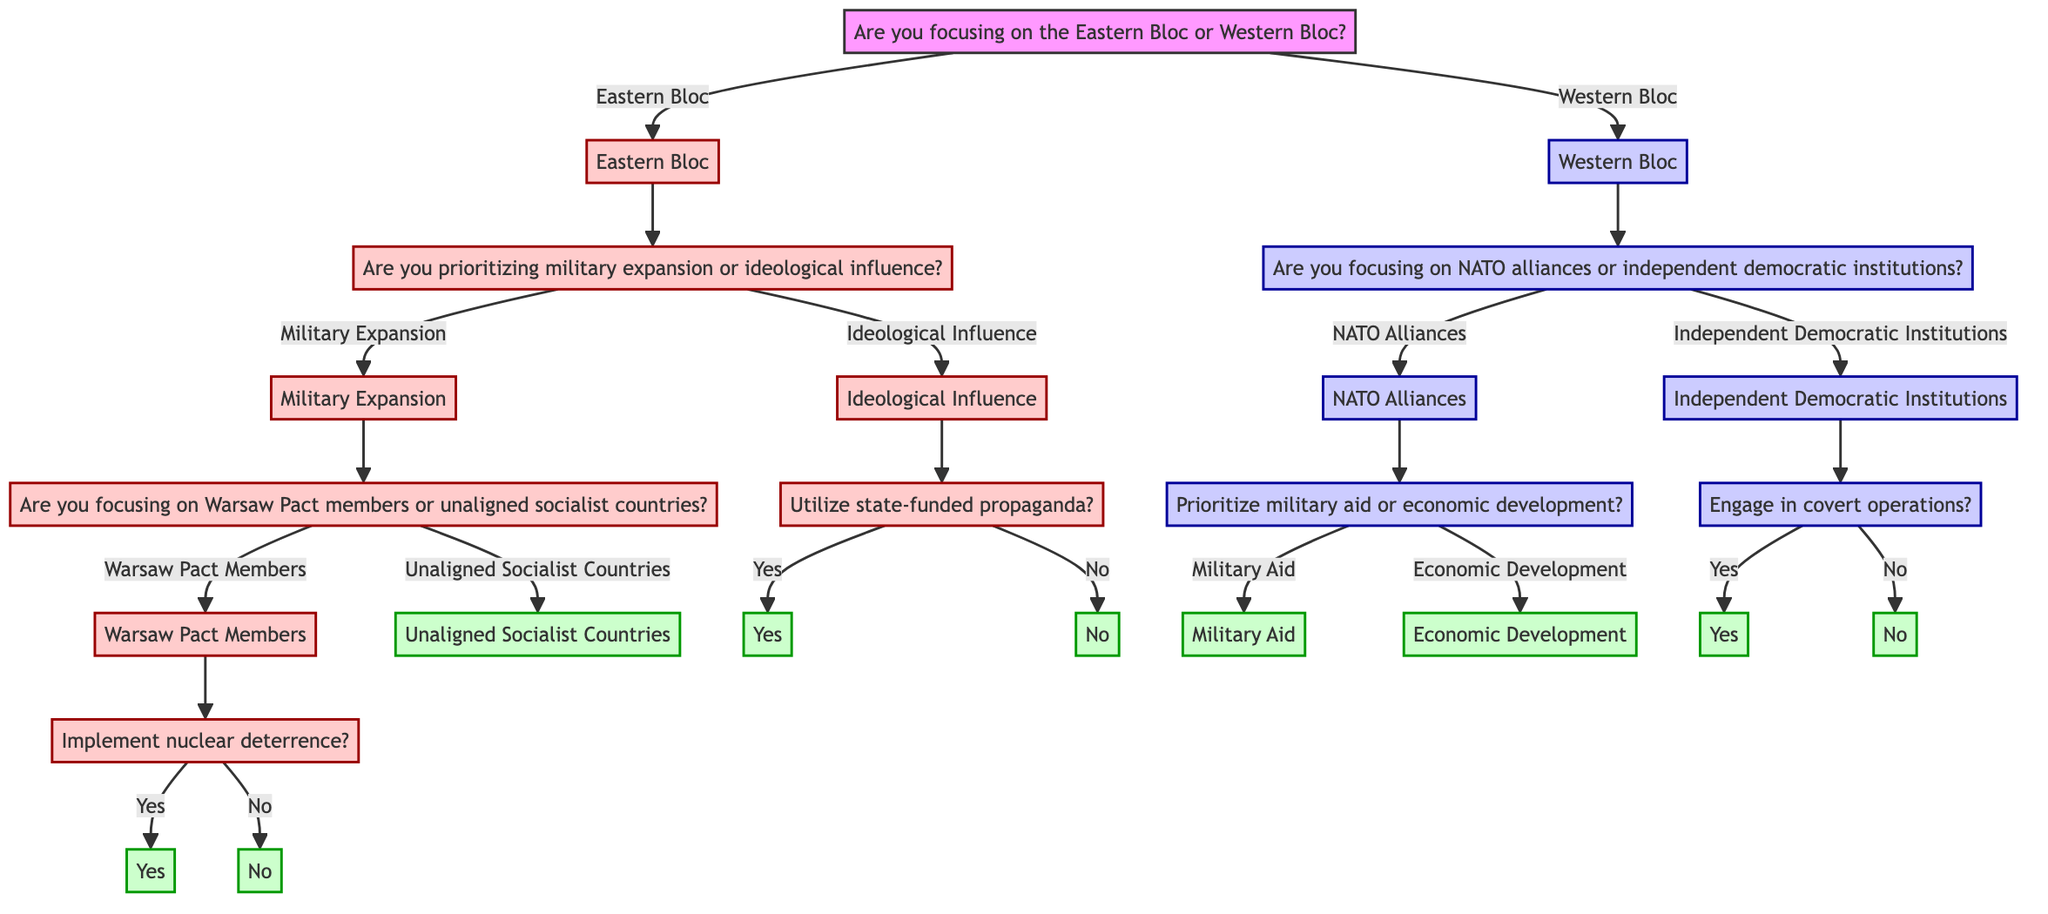What is the first question in the decision tree? The first question, located at the root node, is "Are you focusing on the Eastern Bloc or Western Bloc?" which directs the flow of the decision-making process based on the player's focus.
Answer: Are you focusing on the Eastern Bloc or Western Bloc? How many options are available for the Eastern Bloc strategy? The Eastern Bloc strategy presents two main options: "Military Expansion" and "Ideological Influence." Both options branch out into further questions or results, thus there are two main options to choose from.
Answer: Two Which result comes from prioritizing military expansion and focusing on unaligned socialist countries? Choosing military expansion and focusing on unaligned socialist countries leads to the result: "Offering military aid and economic support to gain influence." This is derived from the flow of choices starting from military expansion down to the specific country focus.
Answer: Offering military aid and economic support to gain influence What is the outcome if you choose NATO alliances and prioritize military aid? If you select NATO alliances and prioritize military aid, it leads to the result: "Strengthening NATO through advanced weaponry and training." This conclusion is reached by following the path from NATO alliances to military aid.
Answer: Strengthening NATO through advanced weaponry and training What is the relationship between ideological influence and state-funded propaganda utilization? Ideological influence is a strategy option that leads to questioning whether to utilize state-funded propaganda. If the answer is yes, it leads to broadening ideological reach; if no, it relies on diplomatic movements. This indicates a direct decision point based on the ideological influence strategy.
Answer: Direct decision point How many distinct outcomes are there for the Western Bloc strategies? For the Western Bloc, there are four distinct outcomes, stemming from the two main branches (NATO alliances and independent democratic institutions) further divided into military aid/economic development and covert operations/diplomatic efforts, respectively.
Answer: Four 